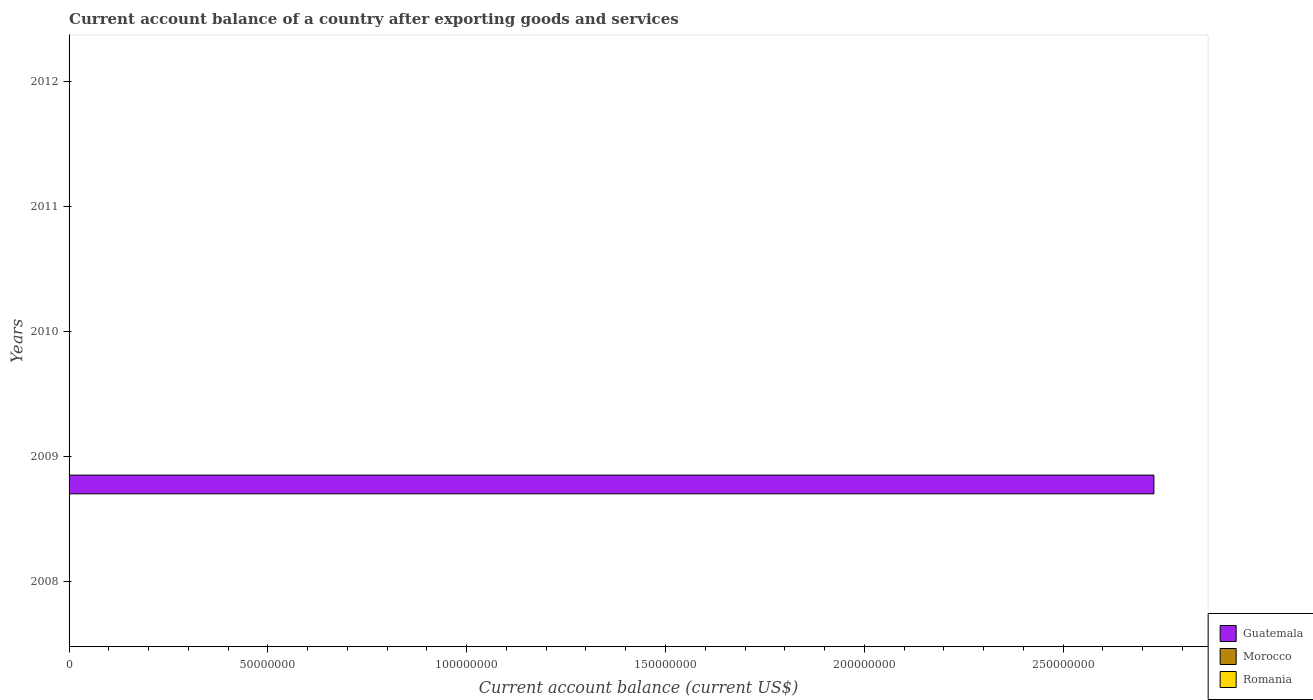Are the number of bars per tick equal to the number of legend labels?
Ensure brevity in your answer.  No. Are the number of bars on each tick of the Y-axis equal?
Make the answer very short. No. How many bars are there on the 3rd tick from the bottom?
Ensure brevity in your answer.  0. What is the label of the 2nd group of bars from the top?
Your response must be concise. 2011. In how many cases, is the number of bars for a given year not equal to the number of legend labels?
Offer a very short reply. 5. Across all years, what is the maximum account balance in Guatemala?
Your answer should be compact. 2.73e+08. In which year was the account balance in Guatemala maximum?
Give a very brief answer. 2009. What is the difference between the account balance in Morocco in 2010 and the account balance in Guatemala in 2008?
Keep it short and to the point. 0. What is the difference between the highest and the lowest account balance in Guatemala?
Your answer should be very brief. 2.73e+08. Is it the case that in every year, the sum of the account balance in Guatemala and account balance in Morocco is greater than the account balance in Romania?
Offer a very short reply. No. How many bars are there?
Your answer should be very brief. 1. Are all the bars in the graph horizontal?
Your response must be concise. Yes. How many years are there in the graph?
Offer a very short reply. 5. Are the values on the major ticks of X-axis written in scientific E-notation?
Your response must be concise. No. Does the graph contain any zero values?
Your answer should be very brief. Yes. Does the graph contain grids?
Your response must be concise. No. Where does the legend appear in the graph?
Offer a very short reply. Bottom right. What is the title of the graph?
Provide a short and direct response. Current account balance of a country after exporting goods and services. Does "Europe(developing only)" appear as one of the legend labels in the graph?
Offer a very short reply. No. What is the label or title of the X-axis?
Keep it short and to the point. Current account balance (current US$). What is the Current account balance (current US$) in Guatemala in 2008?
Ensure brevity in your answer.  0. What is the Current account balance (current US$) in Romania in 2008?
Your answer should be very brief. 0. What is the Current account balance (current US$) of Guatemala in 2009?
Provide a short and direct response. 2.73e+08. What is the Current account balance (current US$) of Morocco in 2009?
Give a very brief answer. 0. What is the Current account balance (current US$) of Guatemala in 2012?
Offer a terse response. 0. What is the Current account balance (current US$) of Morocco in 2012?
Ensure brevity in your answer.  0. Across all years, what is the maximum Current account balance (current US$) of Guatemala?
Give a very brief answer. 2.73e+08. Across all years, what is the minimum Current account balance (current US$) of Guatemala?
Your response must be concise. 0. What is the total Current account balance (current US$) in Guatemala in the graph?
Ensure brevity in your answer.  2.73e+08. What is the average Current account balance (current US$) in Guatemala per year?
Ensure brevity in your answer.  5.46e+07. What is the average Current account balance (current US$) of Morocco per year?
Ensure brevity in your answer.  0. What is the average Current account balance (current US$) in Romania per year?
Your response must be concise. 0. What is the difference between the highest and the lowest Current account balance (current US$) of Guatemala?
Offer a very short reply. 2.73e+08. 